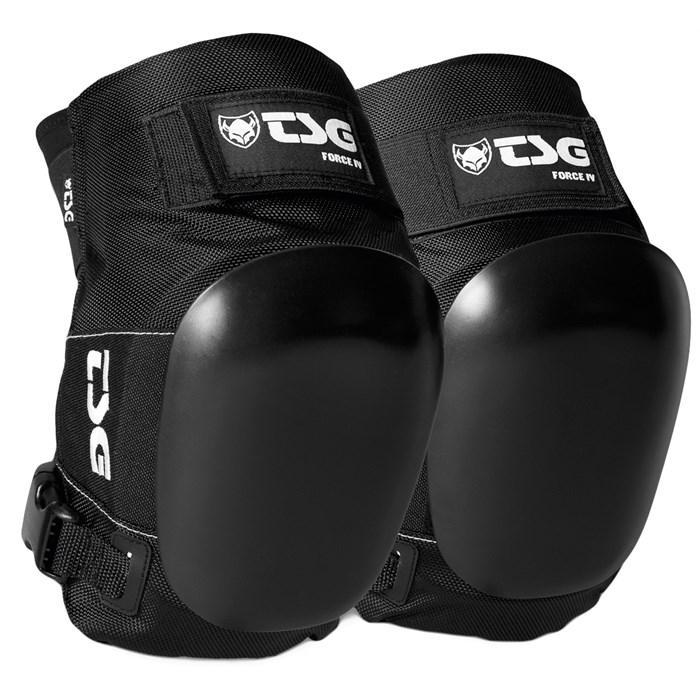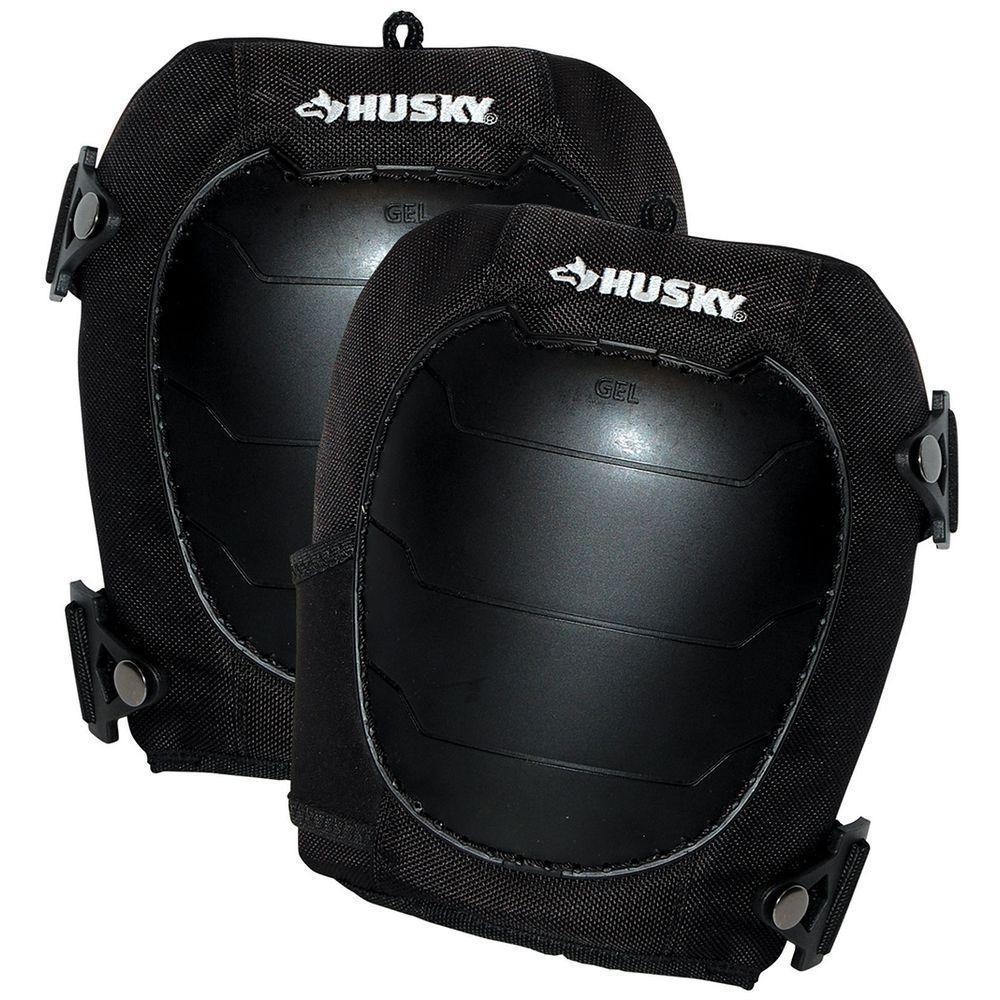The first image is the image on the left, the second image is the image on the right. Analyze the images presented: Is the assertion "An image shows a black knee pad modeled on a human leg." valid? Answer yes or no. No. The first image is the image on the left, the second image is the image on the right. Assess this claim about the two images: "A person is modeling the knee pads in one of the images.". Correct or not? Answer yes or no. No. 